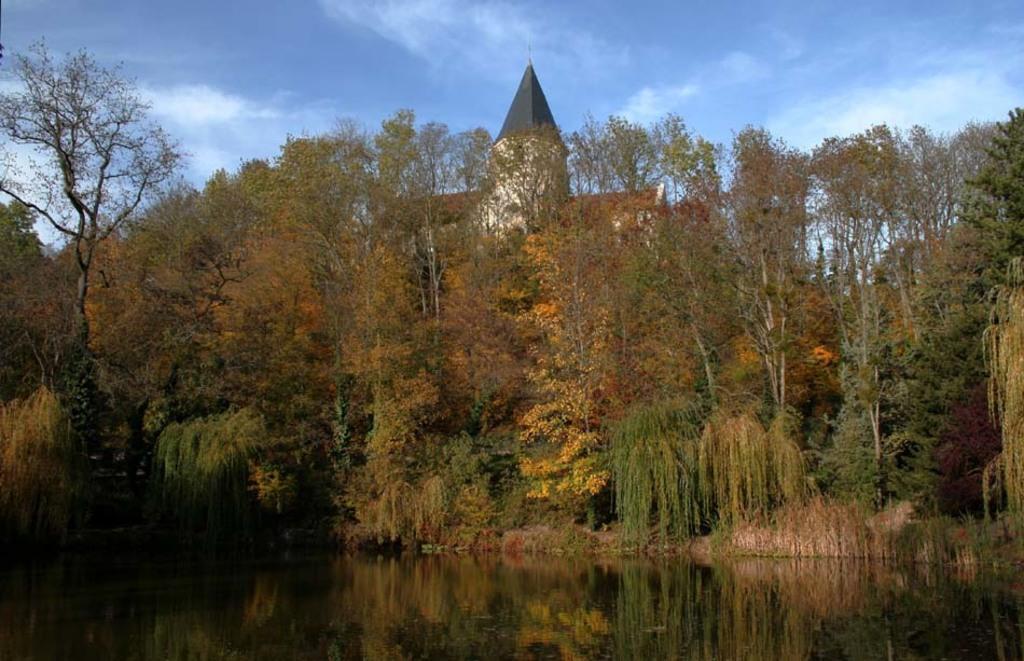In one or two sentences, can you explain what this image depicts? In this image there are trees. At the bottom there is water and we can see a building. In the background there is sky. 